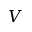Convert formula to latex. <formula><loc_0><loc_0><loc_500><loc_500>V</formula> 